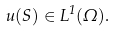Convert formula to latex. <formula><loc_0><loc_0><loc_500><loc_500>u ( S ) \in L ^ { 1 } ( \Omega ) .</formula> 